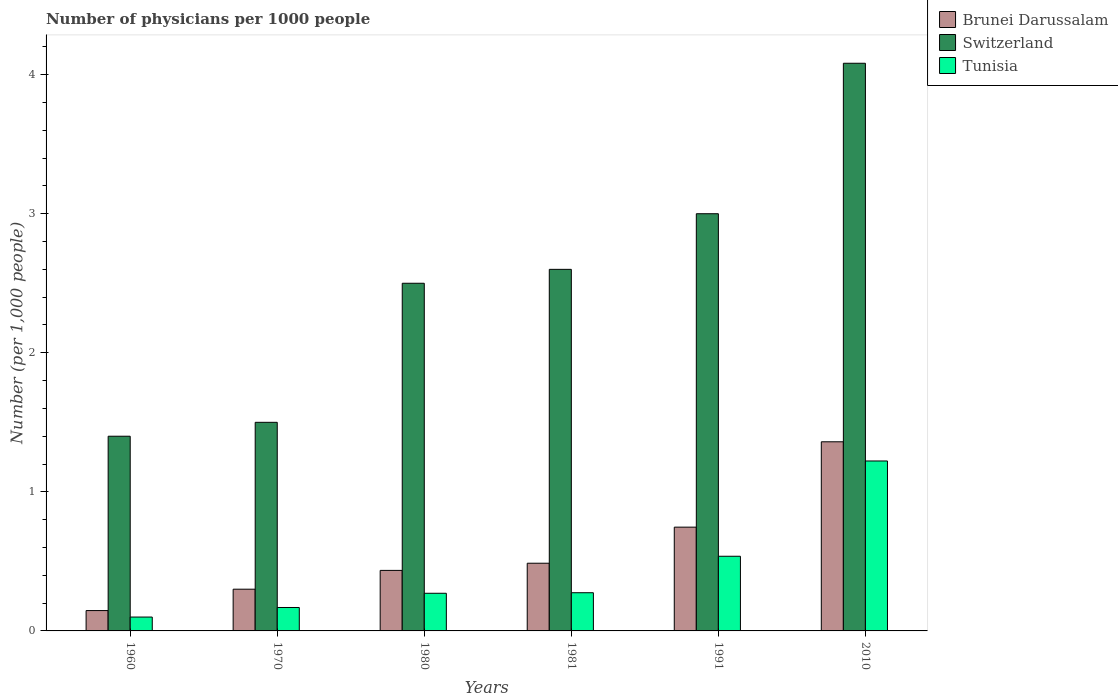How many different coloured bars are there?
Ensure brevity in your answer.  3. What is the label of the 2nd group of bars from the left?
Offer a very short reply. 1970. What is the number of physicians in Tunisia in 2010?
Keep it short and to the point. 1.22. Across all years, what is the maximum number of physicians in Tunisia?
Give a very brief answer. 1.22. Across all years, what is the minimum number of physicians in Brunei Darussalam?
Offer a terse response. 0.15. In which year was the number of physicians in Brunei Darussalam maximum?
Keep it short and to the point. 2010. What is the total number of physicians in Tunisia in the graph?
Make the answer very short. 2.57. What is the difference between the number of physicians in Tunisia in 1970 and that in 1991?
Your answer should be compact. -0.37. What is the difference between the number of physicians in Switzerland in 1981 and the number of physicians in Brunei Darussalam in 1970?
Offer a very short reply. 2.3. What is the average number of physicians in Brunei Darussalam per year?
Your answer should be very brief. 0.58. In the year 1980, what is the difference between the number of physicians in Brunei Darussalam and number of physicians in Tunisia?
Your answer should be compact. 0.16. In how many years, is the number of physicians in Brunei Darussalam greater than 3.6?
Your answer should be very brief. 0. What is the ratio of the number of physicians in Brunei Darussalam in 1980 to that in 2010?
Offer a very short reply. 0.32. Is the number of physicians in Switzerland in 1960 less than that in 1980?
Keep it short and to the point. Yes. Is the difference between the number of physicians in Brunei Darussalam in 1960 and 2010 greater than the difference between the number of physicians in Tunisia in 1960 and 2010?
Provide a succinct answer. No. What is the difference between the highest and the second highest number of physicians in Tunisia?
Give a very brief answer. 0.69. What is the difference between the highest and the lowest number of physicians in Brunei Darussalam?
Your answer should be compact. 1.21. In how many years, is the number of physicians in Switzerland greater than the average number of physicians in Switzerland taken over all years?
Offer a terse response. 3. What does the 3rd bar from the left in 1991 represents?
Offer a terse response. Tunisia. What does the 1st bar from the right in 1991 represents?
Offer a very short reply. Tunisia. How many bars are there?
Make the answer very short. 18. How many years are there in the graph?
Your answer should be very brief. 6. What is the difference between two consecutive major ticks on the Y-axis?
Provide a succinct answer. 1. Does the graph contain any zero values?
Provide a short and direct response. No. Where does the legend appear in the graph?
Ensure brevity in your answer.  Top right. How are the legend labels stacked?
Keep it short and to the point. Vertical. What is the title of the graph?
Your response must be concise. Number of physicians per 1000 people. Does "Austria" appear as one of the legend labels in the graph?
Make the answer very short. No. What is the label or title of the Y-axis?
Your response must be concise. Number (per 1,0 people). What is the Number (per 1,000 people) of Brunei Darussalam in 1960?
Ensure brevity in your answer.  0.15. What is the Number (per 1,000 people) in Switzerland in 1960?
Your answer should be very brief. 1.4. What is the Number (per 1,000 people) of Tunisia in 1960?
Provide a short and direct response. 0.1. What is the Number (per 1,000 people) of Brunei Darussalam in 1970?
Your answer should be compact. 0.3. What is the Number (per 1,000 people) in Tunisia in 1970?
Keep it short and to the point. 0.17. What is the Number (per 1,000 people) of Brunei Darussalam in 1980?
Give a very brief answer. 0.44. What is the Number (per 1,000 people) in Tunisia in 1980?
Your answer should be very brief. 0.27. What is the Number (per 1,000 people) in Brunei Darussalam in 1981?
Your response must be concise. 0.49. What is the Number (per 1,000 people) of Switzerland in 1981?
Keep it short and to the point. 2.6. What is the Number (per 1,000 people) of Tunisia in 1981?
Provide a short and direct response. 0.27. What is the Number (per 1,000 people) in Brunei Darussalam in 1991?
Keep it short and to the point. 0.75. What is the Number (per 1,000 people) in Switzerland in 1991?
Give a very brief answer. 3. What is the Number (per 1,000 people) in Tunisia in 1991?
Your answer should be very brief. 0.54. What is the Number (per 1,000 people) in Brunei Darussalam in 2010?
Offer a very short reply. 1.36. What is the Number (per 1,000 people) of Switzerland in 2010?
Your answer should be compact. 4.08. What is the Number (per 1,000 people) of Tunisia in 2010?
Ensure brevity in your answer.  1.22. Across all years, what is the maximum Number (per 1,000 people) in Brunei Darussalam?
Provide a succinct answer. 1.36. Across all years, what is the maximum Number (per 1,000 people) in Switzerland?
Offer a very short reply. 4.08. Across all years, what is the maximum Number (per 1,000 people) in Tunisia?
Ensure brevity in your answer.  1.22. Across all years, what is the minimum Number (per 1,000 people) in Brunei Darussalam?
Keep it short and to the point. 0.15. Across all years, what is the minimum Number (per 1,000 people) in Tunisia?
Make the answer very short. 0.1. What is the total Number (per 1,000 people) in Brunei Darussalam in the graph?
Your response must be concise. 3.47. What is the total Number (per 1,000 people) of Switzerland in the graph?
Keep it short and to the point. 15.08. What is the total Number (per 1,000 people) of Tunisia in the graph?
Provide a succinct answer. 2.57. What is the difference between the Number (per 1,000 people) of Brunei Darussalam in 1960 and that in 1970?
Offer a terse response. -0.15. What is the difference between the Number (per 1,000 people) in Tunisia in 1960 and that in 1970?
Provide a short and direct response. -0.07. What is the difference between the Number (per 1,000 people) in Brunei Darussalam in 1960 and that in 1980?
Provide a short and direct response. -0.29. What is the difference between the Number (per 1,000 people) of Tunisia in 1960 and that in 1980?
Your response must be concise. -0.17. What is the difference between the Number (per 1,000 people) in Brunei Darussalam in 1960 and that in 1981?
Offer a very short reply. -0.34. What is the difference between the Number (per 1,000 people) of Tunisia in 1960 and that in 1981?
Make the answer very short. -0.17. What is the difference between the Number (per 1,000 people) of Brunei Darussalam in 1960 and that in 1991?
Offer a very short reply. -0.6. What is the difference between the Number (per 1,000 people) of Tunisia in 1960 and that in 1991?
Your answer should be compact. -0.44. What is the difference between the Number (per 1,000 people) of Brunei Darussalam in 1960 and that in 2010?
Your response must be concise. -1.21. What is the difference between the Number (per 1,000 people) of Switzerland in 1960 and that in 2010?
Offer a very short reply. -2.68. What is the difference between the Number (per 1,000 people) of Tunisia in 1960 and that in 2010?
Your response must be concise. -1.12. What is the difference between the Number (per 1,000 people) of Brunei Darussalam in 1970 and that in 1980?
Offer a terse response. -0.14. What is the difference between the Number (per 1,000 people) in Switzerland in 1970 and that in 1980?
Offer a terse response. -1. What is the difference between the Number (per 1,000 people) of Tunisia in 1970 and that in 1980?
Your answer should be compact. -0.1. What is the difference between the Number (per 1,000 people) in Brunei Darussalam in 1970 and that in 1981?
Ensure brevity in your answer.  -0.19. What is the difference between the Number (per 1,000 people) of Tunisia in 1970 and that in 1981?
Ensure brevity in your answer.  -0.11. What is the difference between the Number (per 1,000 people) in Brunei Darussalam in 1970 and that in 1991?
Ensure brevity in your answer.  -0.45. What is the difference between the Number (per 1,000 people) of Switzerland in 1970 and that in 1991?
Offer a very short reply. -1.5. What is the difference between the Number (per 1,000 people) in Tunisia in 1970 and that in 1991?
Keep it short and to the point. -0.37. What is the difference between the Number (per 1,000 people) of Brunei Darussalam in 1970 and that in 2010?
Provide a succinct answer. -1.06. What is the difference between the Number (per 1,000 people) of Switzerland in 1970 and that in 2010?
Your answer should be compact. -2.58. What is the difference between the Number (per 1,000 people) of Tunisia in 1970 and that in 2010?
Provide a succinct answer. -1.05. What is the difference between the Number (per 1,000 people) in Brunei Darussalam in 1980 and that in 1981?
Make the answer very short. -0.05. What is the difference between the Number (per 1,000 people) of Tunisia in 1980 and that in 1981?
Make the answer very short. -0. What is the difference between the Number (per 1,000 people) of Brunei Darussalam in 1980 and that in 1991?
Offer a terse response. -0.31. What is the difference between the Number (per 1,000 people) in Switzerland in 1980 and that in 1991?
Offer a terse response. -0.5. What is the difference between the Number (per 1,000 people) of Tunisia in 1980 and that in 1991?
Provide a succinct answer. -0.27. What is the difference between the Number (per 1,000 people) in Brunei Darussalam in 1980 and that in 2010?
Offer a terse response. -0.92. What is the difference between the Number (per 1,000 people) in Switzerland in 1980 and that in 2010?
Offer a very short reply. -1.58. What is the difference between the Number (per 1,000 people) in Tunisia in 1980 and that in 2010?
Give a very brief answer. -0.95. What is the difference between the Number (per 1,000 people) of Brunei Darussalam in 1981 and that in 1991?
Make the answer very short. -0.26. What is the difference between the Number (per 1,000 people) in Switzerland in 1981 and that in 1991?
Keep it short and to the point. -0.4. What is the difference between the Number (per 1,000 people) in Tunisia in 1981 and that in 1991?
Your answer should be compact. -0.26. What is the difference between the Number (per 1,000 people) of Brunei Darussalam in 1981 and that in 2010?
Offer a terse response. -0.87. What is the difference between the Number (per 1,000 people) of Switzerland in 1981 and that in 2010?
Offer a terse response. -1.48. What is the difference between the Number (per 1,000 people) of Tunisia in 1981 and that in 2010?
Your answer should be compact. -0.95. What is the difference between the Number (per 1,000 people) in Brunei Darussalam in 1991 and that in 2010?
Your answer should be very brief. -0.61. What is the difference between the Number (per 1,000 people) in Switzerland in 1991 and that in 2010?
Make the answer very short. -1.08. What is the difference between the Number (per 1,000 people) of Tunisia in 1991 and that in 2010?
Ensure brevity in your answer.  -0.69. What is the difference between the Number (per 1,000 people) in Brunei Darussalam in 1960 and the Number (per 1,000 people) in Switzerland in 1970?
Provide a succinct answer. -1.35. What is the difference between the Number (per 1,000 people) of Brunei Darussalam in 1960 and the Number (per 1,000 people) of Tunisia in 1970?
Your answer should be very brief. -0.02. What is the difference between the Number (per 1,000 people) in Switzerland in 1960 and the Number (per 1,000 people) in Tunisia in 1970?
Offer a very short reply. 1.23. What is the difference between the Number (per 1,000 people) in Brunei Darussalam in 1960 and the Number (per 1,000 people) in Switzerland in 1980?
Offer a very short reply. -2.35. What is the difference between the Number (per 1,000 people) of Brunei Darussalam in 1960 and the Number (per 1,000 people) of Tunisia in 1980?
Ensure brevity in your answer.  -0.12. What is the difference between the Number (per 1,000 people) of Switzerland in 1960 and the Number (per 1,000 people) of Tunisia in 1980?
Keep it short and to the point. 1.13. What is the difference between the Number (per 1,000 people) of Brunei Darussalam in 1960 and the Number (per 1,000 people) of Switzerland in 1981?
Give a very brief answer. -2.45. What is the difference between the Number (per 1,000 people) of Brunei Darussalam in 1960 and the Number (per 1,000 people) of Tunisia in 1981?
Your answer should be compact. -0.13. What is the difference between the Number (per 1,000 people) of Switzerland in 1960 and the Number (per 1,000 people) of Tunisia in 1981?
Ensure brevity in your answer.  1.13. What is the difference between the Number (per 1,000 people) in Brunei Darussalam in 1960 and the Number (per 1,000 people) in Switzerland in 1991?
Provide a short and direct response. -2.85. What is the difference between the Number (per 1,000 people) in Brunei Darussalam in 1960 and the Number (per 1,000 people) in Tunisia in 1991?
Your answer should be compact. -0.39. What is the difference between the Number (per 1,000 people) of Switzerland in 1960 and the Number (per 1,000 people) of Tunisia in 1991?
Ensure brevity in your answer.  0.86. What is the difference between the Number (per 1,000 people) of Brunei Darussalam in 1960 and the Number (per 1,000 people) of Switzerland in 2010?
Ensure brevity in your answer.  -3.94. What is the difference between the Number (per 1,000 people) of Brunei Darussalam in 1960 and the Number (per 1,000 people) of Tunisia in 2010?
Ensure brevity in your answer.  -1.08. What is the difference between the Number (per 1,000 people) of Switzerland in 1960 and the Number (per 1,000 people) of Tunisia in 2010?
Your answer should be compact. 0.18. What is the difference between the Number (per 1,000 people) of Brunei Darussalam in 1970 and the Number (per 1,000 people) of Switzerland in 1980?
Offer a very short reply. -2.2. What is the difference between the Number (per 1,000 people) of Brunei Darussalam in 1970 and the Number (per 1,000 people) of Tunisia in 1980?
Your answer should be compact. 0.03. What is the difference between the Number (per 1,000 people) of Switzerland in 1970 and the Number (per 1,000 people) of Tunisia in 1980?
Your answer should be very brief. 1.23. What is the difference between the Number (per 1,000 people) in Brunei Darussalam in 1970 and the Number (per 1,000 people) in Switzerland in 1981?
Provide a short and direct response. -2.3. What is the difference between the Number (per 1,000 people) in Brunei Darussalam in 1970 and the Number (per 1,000 people) in Tunisia in 1981?
Your response must be concise. 0.03. What is the difference between the Number (per 1,000 people) of Switzerland in 1970 and the Number (per 1,000 people) of Tunisia in 1981?
Keep it short and to the point. 1.23. What is the difference between the Number (per 1,000 people) of Brunei Darussalam in 1970 and the Number (per 1,000 people) of Tunisia in 1991?
Keep it short and to the point. -0.24. What is the difference between the Number (per 1,000 people) of Switzerland in 1970 and the Number (per 1,000 people) of Tunisia in 1991?
Provide a succinct answer. 0.96. What is the difference between the Number (per 1,000 people) of Brunei Darussalam in 1970 and the Number (per 1,000 people) of Switzerland in 2010?
Ensure brevity in your answer.  -3.78. What is the difference between the Number (per 1,000 people) in Brunei Darussalam in 1970 and the Number (per 1,000 people) in Tunisia in 2010?
Make the answer very short. -0.92. What is the difference between the Number (per 1,000 people) in Switzerland in 1970 and the Number (per 1,000 people) in Tunisia in 2010?
Give a very brief answer. 0.28. What is the difference between the Number (per 1,000 people) in Brunei Darussalam in 1980 and the Number (per 1,000 people) in Switzerland in 1981?
Make the answer very short. -2.16. What is the difference between the Number (per 1,000 people) of Brunei Darussalam in 1980 and the Number (per 1,000 people) of Tunisia in 1981?
Ensure brevity in your answer.  0.16. What is the difference between the Number (per 1,000 people) of Switzerland in 1980 and the Number (per 1,000 people) of Tunisia in 1981?
Keep it short and to the point. 2.23. What is the difference between the Number (per 1,000 people) in Brunei Darussalam in 1980 and the Number (per 1,000 people) in Switzerland in 1991?
Provide a succinct answer. -2.56. What is the difference between the Number (per 1,000 people) of Brunei Darussalam in 1980 and the Number (per 1,000 people) of Tunisia in 1991?
Your response must be concise. -0.1. What is the difference between the Number (per 1,000 people) in Switzerland in 1980 and the Number (per 1,000 people) in Tunisia in 1991?
Offer a terse response. 1.96. What is the difference between the Number (per 1,000 people) in Brunei Darussalam in 1980 and the Number (per 1,000 people) in Switzerland in 2010?
Your answer should be compact. -3.65. What is the difference between the Number (per 1,000 people) of Brunei Darussalam in 1980 and the Number (per 1,000 people) of Tunisia in 2010?
Offer a terse response. -0.79. What is the difference between the Number (per 1,000 people) in Switzerland in 1980 and the Number (per 1,000 people) in Tunisia in 2010?
Ensure brevity in your answer.  1.28. What is the difference between the Number (per 1,000 people) of Brunei Darussalam in 1981 and the Number (per 1,000 people) of Switzerland in 1991?
Give a very brief answer. -2.51. What is the difference between the Number (per 1,000 people) of Brunei Darussalam in 1981 and the Number (per 1,000 people) of Tunisia in 1991?
Your answer should be very brief. -0.05. What is the difference between the Number (per 1,000 people) of Switzerland in 1981 and the Number (per 1,000 people) of Tunisia in 1991?
Ensure brevity in your answer.  2.06. What is the difference between the Number (per 1,000 people) in Brunei Darussalam in 1981 and the Number (per 1,000 people) in Switzerland in 2010?
Ensure brevity in your answer.  -3.6. What is the difference between the Number (per 1,000 people) in Brunei Darussalam in 1981 and the Number (per 1,000 people) in Tunisia in 2010?
Give a very brief answer. -0.74. What is the difference between the Number (per 1,000 people) of Switzerland in 1981 and the Number (per 1,000 people) of Tunisia in 2010?
Provide a short and direct response. 1.38. What is the difference between the Number (per 1,000 people) of Brunei Darussalam in 1991 and the Number (per 1,000 people) of Switzerland in 2010?
Your response must be concise. -3.34. What is the difference between the Number (per 1,000 people) in Brunei Darussalam in 1991 and the Number (per 1,000 people) in Tunisia in 2010?
Provide a short and direct response. -0.48. What is the difference between the Number (per 1,000 people) of Switzerland in 1991 and the Number (per 1,000 people) of Tunisia in 2010?
Offer a terse response. 1.78. What is the average Number (per 1,000 people) of Brunei Darussalam per year?
Make the answer very short. 0.58. What is the average Number (per 1,000 people) of Switzerland per year?
Your answer should be compact. 2.51. What is the average Number (per 1,000 people) of Tunisia per year?
Make the answer very short. 0.43. In the year 1960, what is the difference between the Number (per 1,000 people) of Brunei Darussalam and Number (per 1,000 people) of Switzerland?
Provide a short and direct response. -1.25. In the year 1960, what is the difference between the Number (per 1,000 people) in Brunei Darussalam and Number (per 1,000 people) in Tunisia?
Give a very brief answer. 0.05. In the year 1960, what is the difference between the Number (per 1,000 people) of Switzerland and Number (per 1,000 people) of Tunisia?
Make the answer very short. 1.3. In the year 1970, what is the difference between the Number (per 1,000 people) in Brunei Darussalam and Number (per 1,000 people) in Switzerland?
Give a very brief answer. -1.2. In the year 1970, what is the difference between the Number (per 1,000 people) in Brunei Darussalam and Number (per 1,000 people) in Tunisia?
Make the answer very short. 0.13. In the year 1970, what is the difference between the Number (per 1,000 people) of Switzerland and Number (per 1,000 people) of Tunisia?
Offer a terse response. 1.33. In the year 1980, what is the difference between the Number (per 1,000 people) of Brunei Darussalam and Number (per 1,000 people) of Switzerland?
Your answer should be compact. -2.06. In the year 1980, what is the difference between the Number (per 1,000 people) of Brunei Darussalam and Number (per 1,000 people) of Tunisia?
Your answer should be compact. 0.16. In the year 1980, what is the difference between the Number (per 1,000 people) in Switzerland and Number (per 1,000 people) in Tunisia?
Your answer should be compact. 2.23. In the year 1981, what is the difference between the Number (per 1,000 people) of Brunei Darussalam and Number (per 1,000 people) of Switzerland?
Offer a very short reply. -2.11. In the year 1981, what is the difference between the Number (per 1,000 people) of Brunei Darussalam and Number (per 1,000 people) of Tunisia?
Provide a short and direct response. 0.21. In the year 1981, what is the difference between the Number (per 1,000 people) of Switzerland and Number (per 1,000 people) of Tunisia?
Offer a very short reply. 2.33. In the year 1991, what is the difference between the Number (per 1,000 people) of Brunei Darussalam and Number (per 1,000 people) of Switzerland?
Your answer should be compact. -2.25. In the year 1991, what is the difference between the Number (per 1,000 people) in Brunei Darussalam and Number (per 1,000 people) in Tunisia?
Give a very brief answer. 0.21. In the year 1991, what is the difference between the Number (per 1,000 people) in Switzerland and Number (per 1,000 people) in Tunisia?
Provide a short and direct response. 2.46. In the year 2010, what is the difference between the Number (per 1,000 people) in Brunei Darussalam and Number (per 1,000 people) in Switzerland?
Make the answer very short. -2.72. In the year 2010, what is the difference between the Number (per 1,000 people) of Brunei Darussalam and Number (per 1,000 people) of Tunisia?
Your response must be concise. 0.14. In the year 2010, what is the difference between the Number (per 1,000 people) of Switzerland and Number (per 1,000 people) of Tunisia?
Ensure brevity in your answer.  2.86. What is the ratio of the Number (per 1,000 people) in Brunei Darussalam in 1960 to that in 1970?
Your answer should be very brief. 0.49. What is the ratio of the Number (per 1,000 people) of Switzerland in 1960 to that in 1970?
Your answer should be very brief. 0.93. What is the ratio of the Number (per 1,000 people) in Tunisia in 1960 to that in 1970?
Offer a very short reply. 0.59. What is the ratio of the Number (per 1,000 people) of Brunei Darussalam in 1960 to that in 1980?
Offer a terse response. 0.34. What is the ratio of the Number (per 1,000 people) of Switzerland in 1960 to that in 1980?
Offer a terse response. 0.56. What is the ratio of the Number (per 1,000 people) of Tunisia in 1960 to that in 1980?
Offer a very short reply. 0.37. What is the ratio of the Number (per 1,000 people) of Brunei Darussalam in 1960 to that in 1981?
Provide a succinct answer. 0.3. What is the ratio of the Number (per 1,000 people) in Switzerland in 1960 to that in 1981?
Give a very brief answer. 0.54. What is the ratio of the Number (per 1,000 people) in Tunisia in 1960 to that in 1981?
Provide a short and direct response. 0.36. What is the ratio of the Number (per 1,000 people) in Brunei Darussalam in 1960 to that in 1991?
Provide a short and direct response. 0.2. What is the ratio of the Number (per 1,000 people) of Switzerland in 1960 to that in 1991?
Offer a very short reply. 0.47. What is the ratio of the Number (per 1,000 people) in Tunisia in 1960 to that in 1991?
Keep it short and to the point. 0.19. What is the ratio of the Number (per 1,000 people) of Brunei Darussalam in 1960 to that in 2010?
Ensure brevity in your answer.  0.11. What is the ratio of the Number (per 1,000 people) of Switzerland in 1960 to that in 2010?
Provide a short and direct response. 0.34. What is the ratio of the Number (per 1,000 people) of Tunisia in 1960 to that in 2010?
Provide a short and direct response. 0.08. What is the ratio of the Number (per 1,000 people) in Brunei Darussalam in 1970 to that in 1980?
Ensure brevity in your answer.  0.69. What is the ratio of the Number (per 1,000 people) in Switzerland in 1970 to that in 1980?
Offer a very short reply. 0.6. What is the ratio of the Number (per 1,000 people) of Tunisia in 1970 to that in 1980?
Your answer should be very brief. 0.62. What is the ratio of the Number (per 1,000 people) in Brunei Darussalam in 1970 to that in 1981?
Offer a very short reply. 0.62. What is the ratio of the Number (per 1,000 people) of Switzerland in 1970 to that in 1981?
Offer a very short reply. 0.58. What is the ratio of the Number (per 1,000 people) in Tunisia in 1970 to that in 1981?
Offer a terse response. 0.61. What is the ratio of the Number (per 1,000 people) of Brunei Darussalam in 1970 to that in 1991?
Offer a terse response. 0.4. What is the ratio of the Number (per 1,000 people) of Switzerland in 1970 to that in 1991?
Keep it short and to the point. 0.5. What is the ratio of the Number (per 1,000 people) in Tunisia in 1970 to that in 1991?
Ensure brevity in your answer.  0.31. What is the ratio of the Number (per 1,000 people) in Brunei Darussalam in 1970 to that in 2010?
Keep it short and to the point. 0.22. What is the ratio of the Number (per 1,000 people) of Switzerland in 1970 to that in 2010?
Offer a terse response. 0.37. What is the ratio of the Number (per 1,000 people) in Tunisia in 1970 to that in 2010?
Your response must be concise. 0.14. What is the ratio of the Number (per 1,000 people) of Brunei Darussalam in 1980 to that in 1981?
Offer a terse response. 0.89. What is the ratio of the Number (per 1,000 people) in Switzerland in 1980 to that in 1981?
Keep it short and to the point. 0.96. What is the ratio of the Number (per 1,000 people) of Tunisia in 1980 to that in 1981?
Offer a terse response. 0.99. What is the ratio of the Number (per 1,000 people) in Brunei Darussalam in 1980 to that in 1991?
Your answer should be very brief. 0.58. What is the ratio of the Number (per 1,000 people) of Switzerland in 1980 to that in 1991?
Make the answer very short. 0.83. What is the ratio of the Number (per 1,000 people) of Tunisia in 1980 to that in 1991?
Offer a terse response. 0.5. What is the ratio of the Number (per 1,000 people) of Brunei Darussalam in 1980 to that in 2010?
Give a very brief answer. 0.32. What is the ratio of the Number (per 1,000 people) in Switzerland in 1980 to that in 2010?
Make the answer very short. 0.61. What is the ratio of the Number (per 1,000 people) in Tunisia in 1980 to that in 2010?
Offer a terse response. 0.22. What is the ratio of the Number (per 1,000 people) in Brunei Darussalam in 1981 to that in 1991?
Your answer should be compact. 0.65. What is the ratio of the Number (per 1,000 people) of Switzerland in 1981 to that in 1991?
Your answer should be very brief. 0.87. What is the ratio of the Number (per 1,000 people) in Tunisia in 1981 to that in 1991?
Your answer should be very brief. 0.51. What is the ratio of the Number (per 1,000 people) of Brunei Darussalam in 1981 to that in 2010?
Provide a short and direct response. 0.36. What is the ratio of the Number (per 1,000 people) in Switzerland in 1981 to that in 2010?
Your response must be concise. 0.64. What is the ratio of the Number (per 1,000 people) in Tunisia in 1981 to that in 2010?
Your answer should be compact. 0.22. What is the ratio of the Number (per 1,000 people) of Brunei Darussalam in 1991 to that in 2010?
Provide a succinct answer. 0.55. What is the ratio of the Number (per 1,000 people) of Switzerland in 1991 to that in 2010?
Offer a terse response. 0.73. What is the ratio of the Number (per 1,000 people) of Tunisia in 1991 to that in 2010?
Your answer should be very brief. 0.44. What is the difference between the highest and the second highest Number (per 1,000 people) in Brunei Darussalam?
Keep it short and to the point. 0.61. What is the difference between the highest and the second highest Number (per 1,000 people) in Switzerland?
Keep it short and to the point. 1.08. What is the difference between the highest and the second highest Number (per 1,000 people) of Tunisia?
Provide a short and direct response. 0.69. What is the difference between the highest and the lowest Number (per 1,000 people) of Brunei Darussalam?
Ensure brevity in your answer.  1.21. What is the difference between the highest and the lowest Number (per 1,000 people) of Switzerland?
Your answer should be very brief. 2.68. What is the difference between the highest and the lowest Number (per 1,000 people) of Tunisia?
Provide a succinct answer. 1.12. 